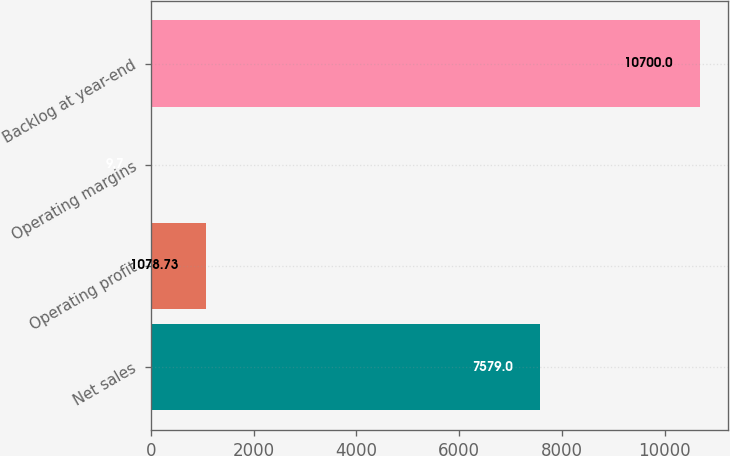<chart> <loc_0><loc_0><loc_500><loc_500><bar_chart><fcel>Net sales<fcel>Operating profit<fcel>Operating margins<fcel>Backlog at year-end<nl><fcel>7579<fcel>1078.73<fcel>9.7<fcel>10700<nl></chart> 